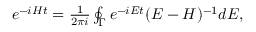<formula> <loc_0><loc_0><loc_500><loc_500>\begin{array} { r } { e ^ { - i H t } = \frac { 1 } { 2 \pi i } \oint _ { \Gamma } e ^ { - i E t } ( E - H ) ^ { - 1 } d E , } \end{array}</formula> 